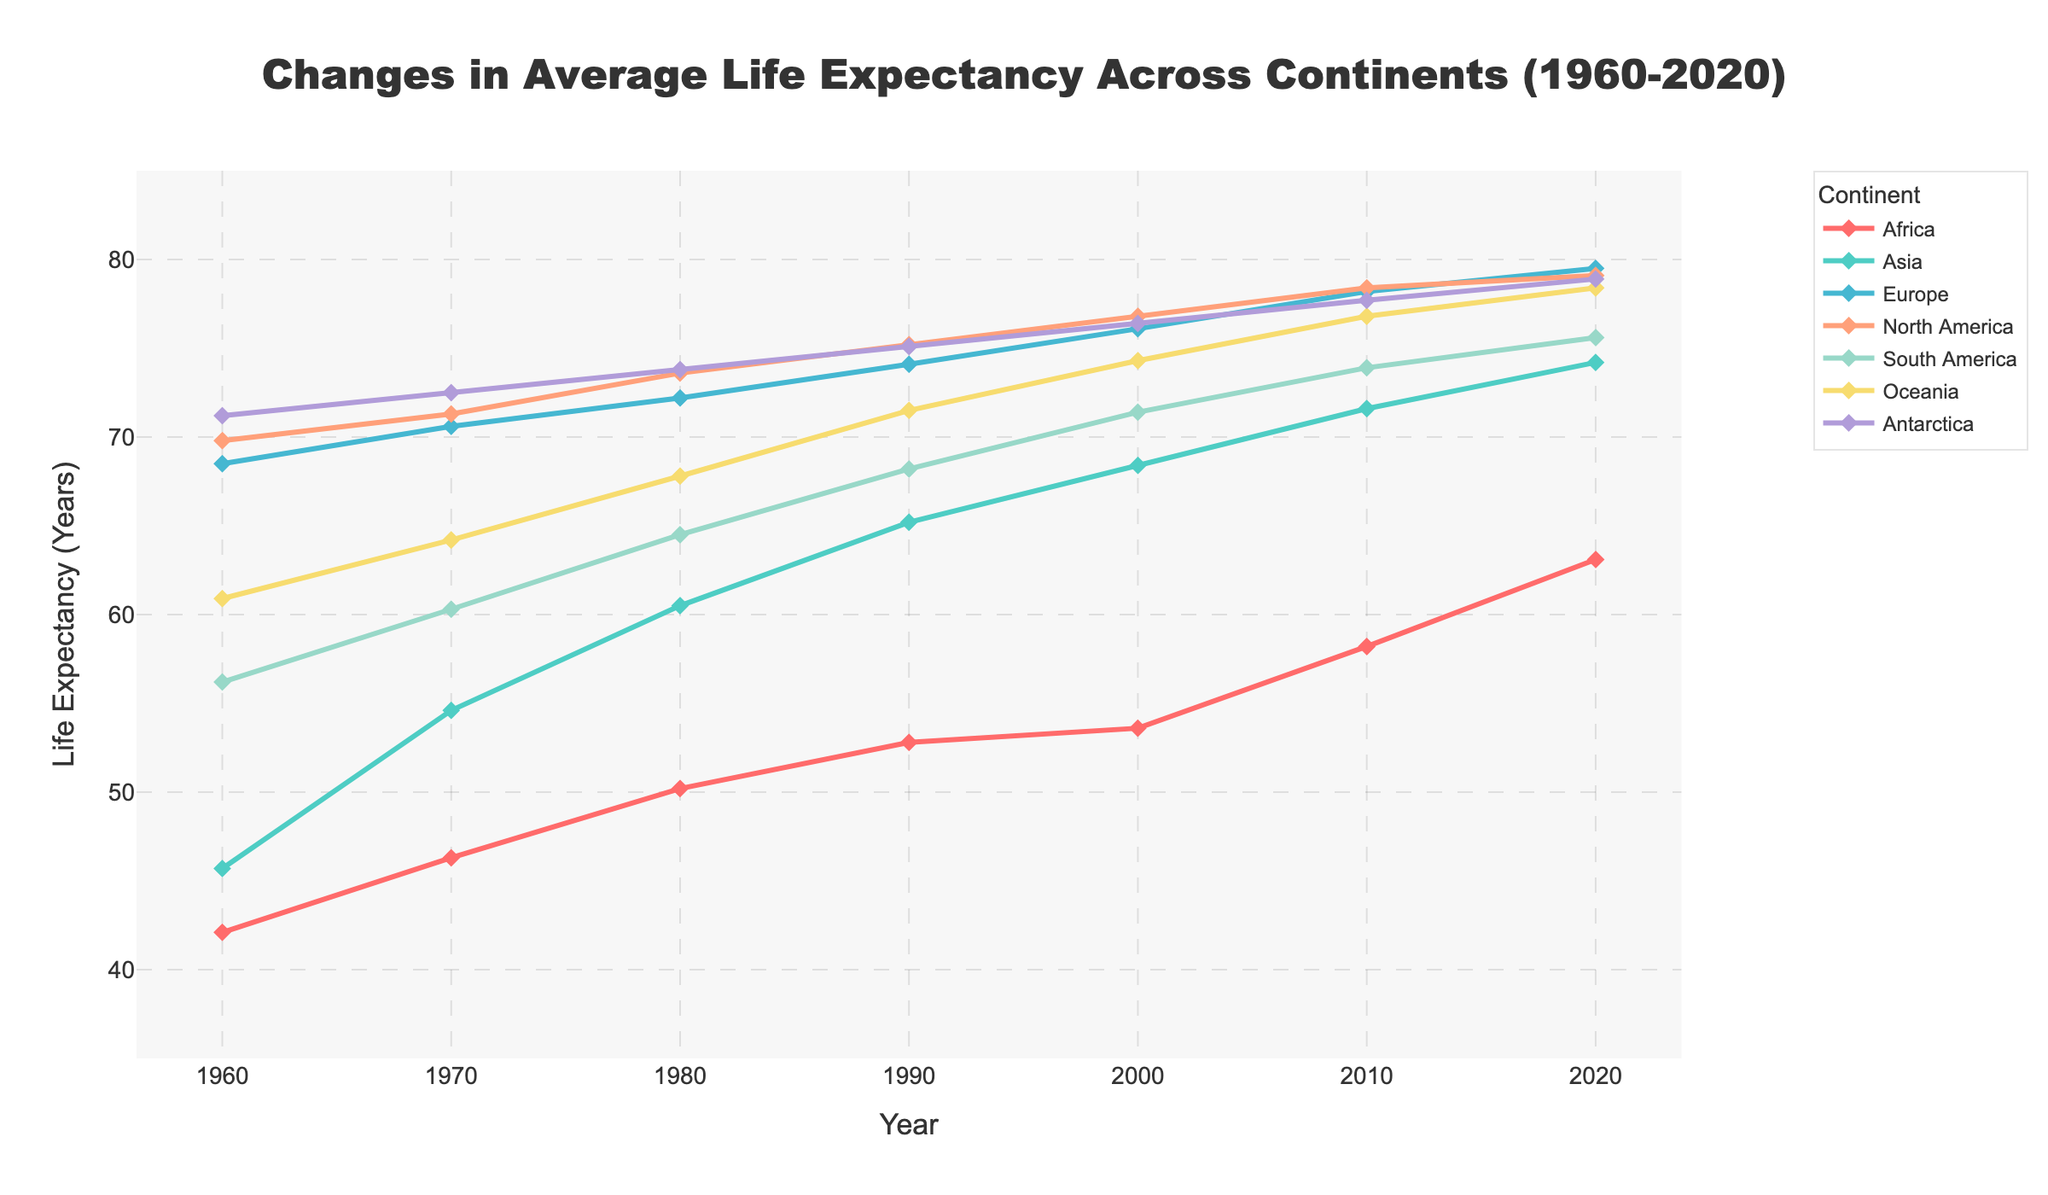What is the overall trend for life expectancy in Africa from 1960 to 2020? The line representing Africa generally trends upwards from 42.1 years in 1960 to 63.1 years in 2020, indicating an increasing life expectancy over the years
Answer: Increasing In which year did Asia surpass a life expectancy of 70 years? By looking at the line for Asia and tracing it across the years, the life expectancy surpasses 70 years around 2010
Answer: 2010 Which continent had the highest life expectancy in 1960? The highest point on the y-axis for the year 1960 corresponds to Antarctica, indicating it had the highest life expectancy at that time
Answer: Antarctica Between 1980 and 2000, which continent shows the greatest increase in life expectancy? Calculate the difference for each continent: Africa (53.6-50.2=3.4), Asia (68.4-60.5=7.9), Europe (76.1-72.2=3.9), North America (76.8-73.6=3.2), South America (71.4-64.5=6.9), Oceania (74.3-67.8=6.5), Antarctica (76.4-73.8=2.6). Asia has the greatest increase of 7.9 years
Answer: Asia How does the life expectancy in North America in 2020 compare to that in Europe in 2020? By looking at the lines for North America and Europe in 2020, North America has a life expectancy of 79.1 years, and Europe has 79.5 years
Answer: Europe is higher Describe the visual difference between the lines representing Asia and Africa. The line for Asia trends more steeply upwards compared to Africa, showing a faster increase in life expectancy. Additionally, the line for Asia is in light blue, while the line for Africa is red
Answer: Asia's line is steeper and blue; Africa's is red Which continents showed a life expectancy above 75 years in 2020? Tracing the lines at the year 2020, Europe (79.5), North America (79.1), Oceania (78.4), and Antarctica (78.9) all have life expectancies above 75 years
Answer: Europe, North America, Oceania, Antarctica What is the difference in life expectancy between South America and Oceania in the year 2000? Looking at the y-axis values for the year 2000, South America has 71.4 years, and Oceania has 74.3 years. The difference is 74.3 - 71.4 = 2.9 years
Answer: 2.9 years Did any continent see a decline in life expectancy at any point from 1960 to 2020? Observing the lines for any downward trend within the time range, none of the continents exhibit a declining pattern, all show an increase
Answer: No 